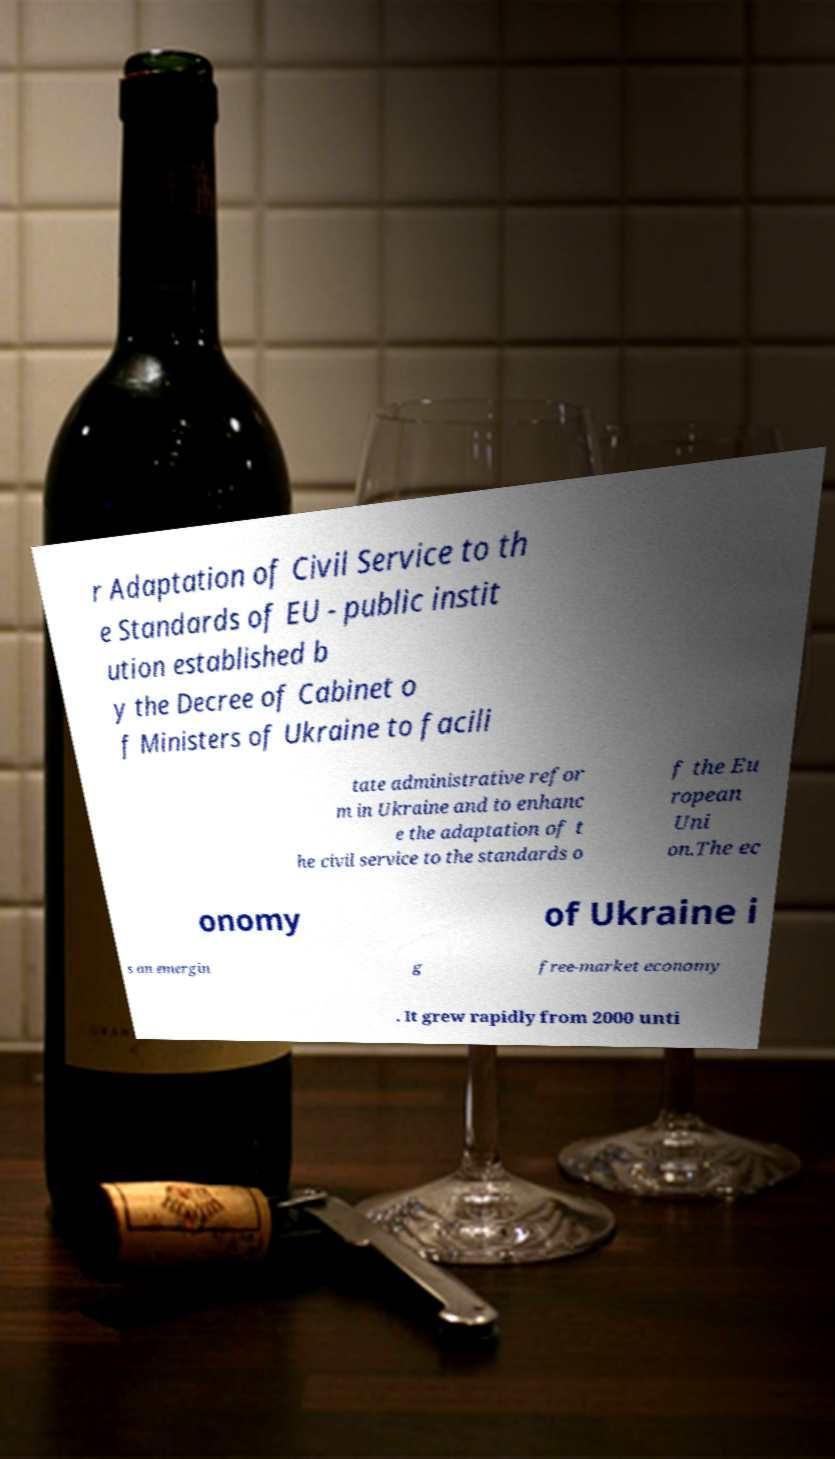Could you extract and type out the text from this image? r Adaptation of Civil Service to th e Standards of EU - public instit ution established b y the Decree of Cabinet o f Ministers of Ukraine to facili tate administrative refor m in Ukraine and to enhanc e the adaptation of t he civil service to the standards o f the Eu ropean Uni on.The ec onomy of Ukraine i s an emergin g free-market economy . It grew rapidly from 2000 unti 